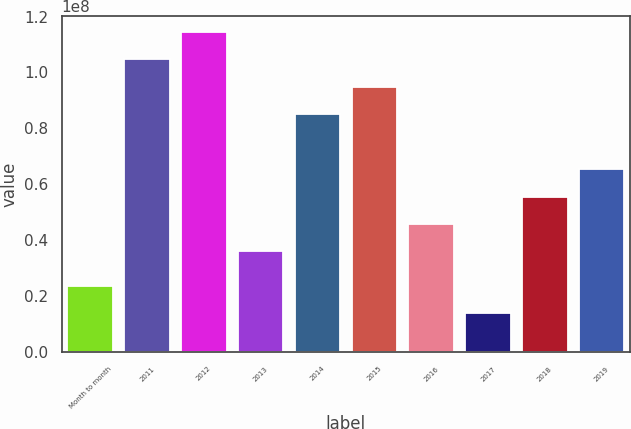Convert chart. <chart><loc_0><loc_0><loc_500><loc_500><bar_chart><fcel>Month to month<fcel>2011<fcel>2012<fcel>2013<fcel>2014<fcel>2015<fcel>2016<fcel>2017<fcel>2018<fcel>2019<nl><fcel>2.38098e+07<fcel>1.0475e+08<fcel>1.14571e+08<fcel>3.5997e+07<fcel>8.5106e+07<fcel>9.49278e+07<fcel>4.58188e+07<fcel>1.3988e+07<fcel>5.56406e+07<fcel>6.54624e+07<nl></chart> 